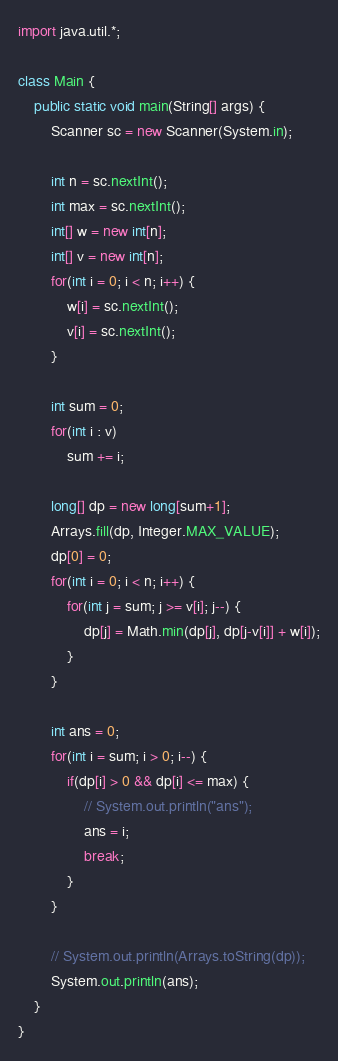Convert code to text. <code><loc_0><loc_0><loc_500><loc_500><_Java_>import java.util.*;

class Main {
    public static void main(String[] args) {
    	Scanner sc = new Scanner(System.in);

    	int n = sc.nextInt();
    	int max = sc.nextInt();
    	int[] w = new int[n];
    	int[] v = new int[n];
    	for(int i = 0; i < n; i++) {
    		w[i] = sc.nextInt();
    		v[i] = sc.nextInt();
    	}

    	int sum = 0;
    	for(int i : v)
    		sum += i;

    	long[] dp = new long[sum+1];
    	Arrays.fill(dp, Integer.MAX_VALUE);
    	dp[0] = 0;
    	for(int i = 0; i < n; i++) {
    		for(int j = sum; j >= v[i]; j--) {
    			dp[j] = Math.min(dp[j], dp[j-v[i]] + w[i]);
    		}
    	}

    	int ans = 0;
    	for(int i = sum; i > 0; i--) {
    		if(dp[i] > 0 && dp[i] <= max) {
    			// System.out.println("ans");
    			ans = i;
    			break;
    		}
    	}

    	// System.out.println(Arrays.toString(dp));
    	System.out.println(ans);
    }
}</code> 